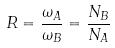Convert formula to latex. <formula><loc_0><loc_0><loc_500><loc_500>R = \frac { \omega _ { A } } { \omega _ { B } } = \frac { N _ { B } } { N _ { A } }</formula> 